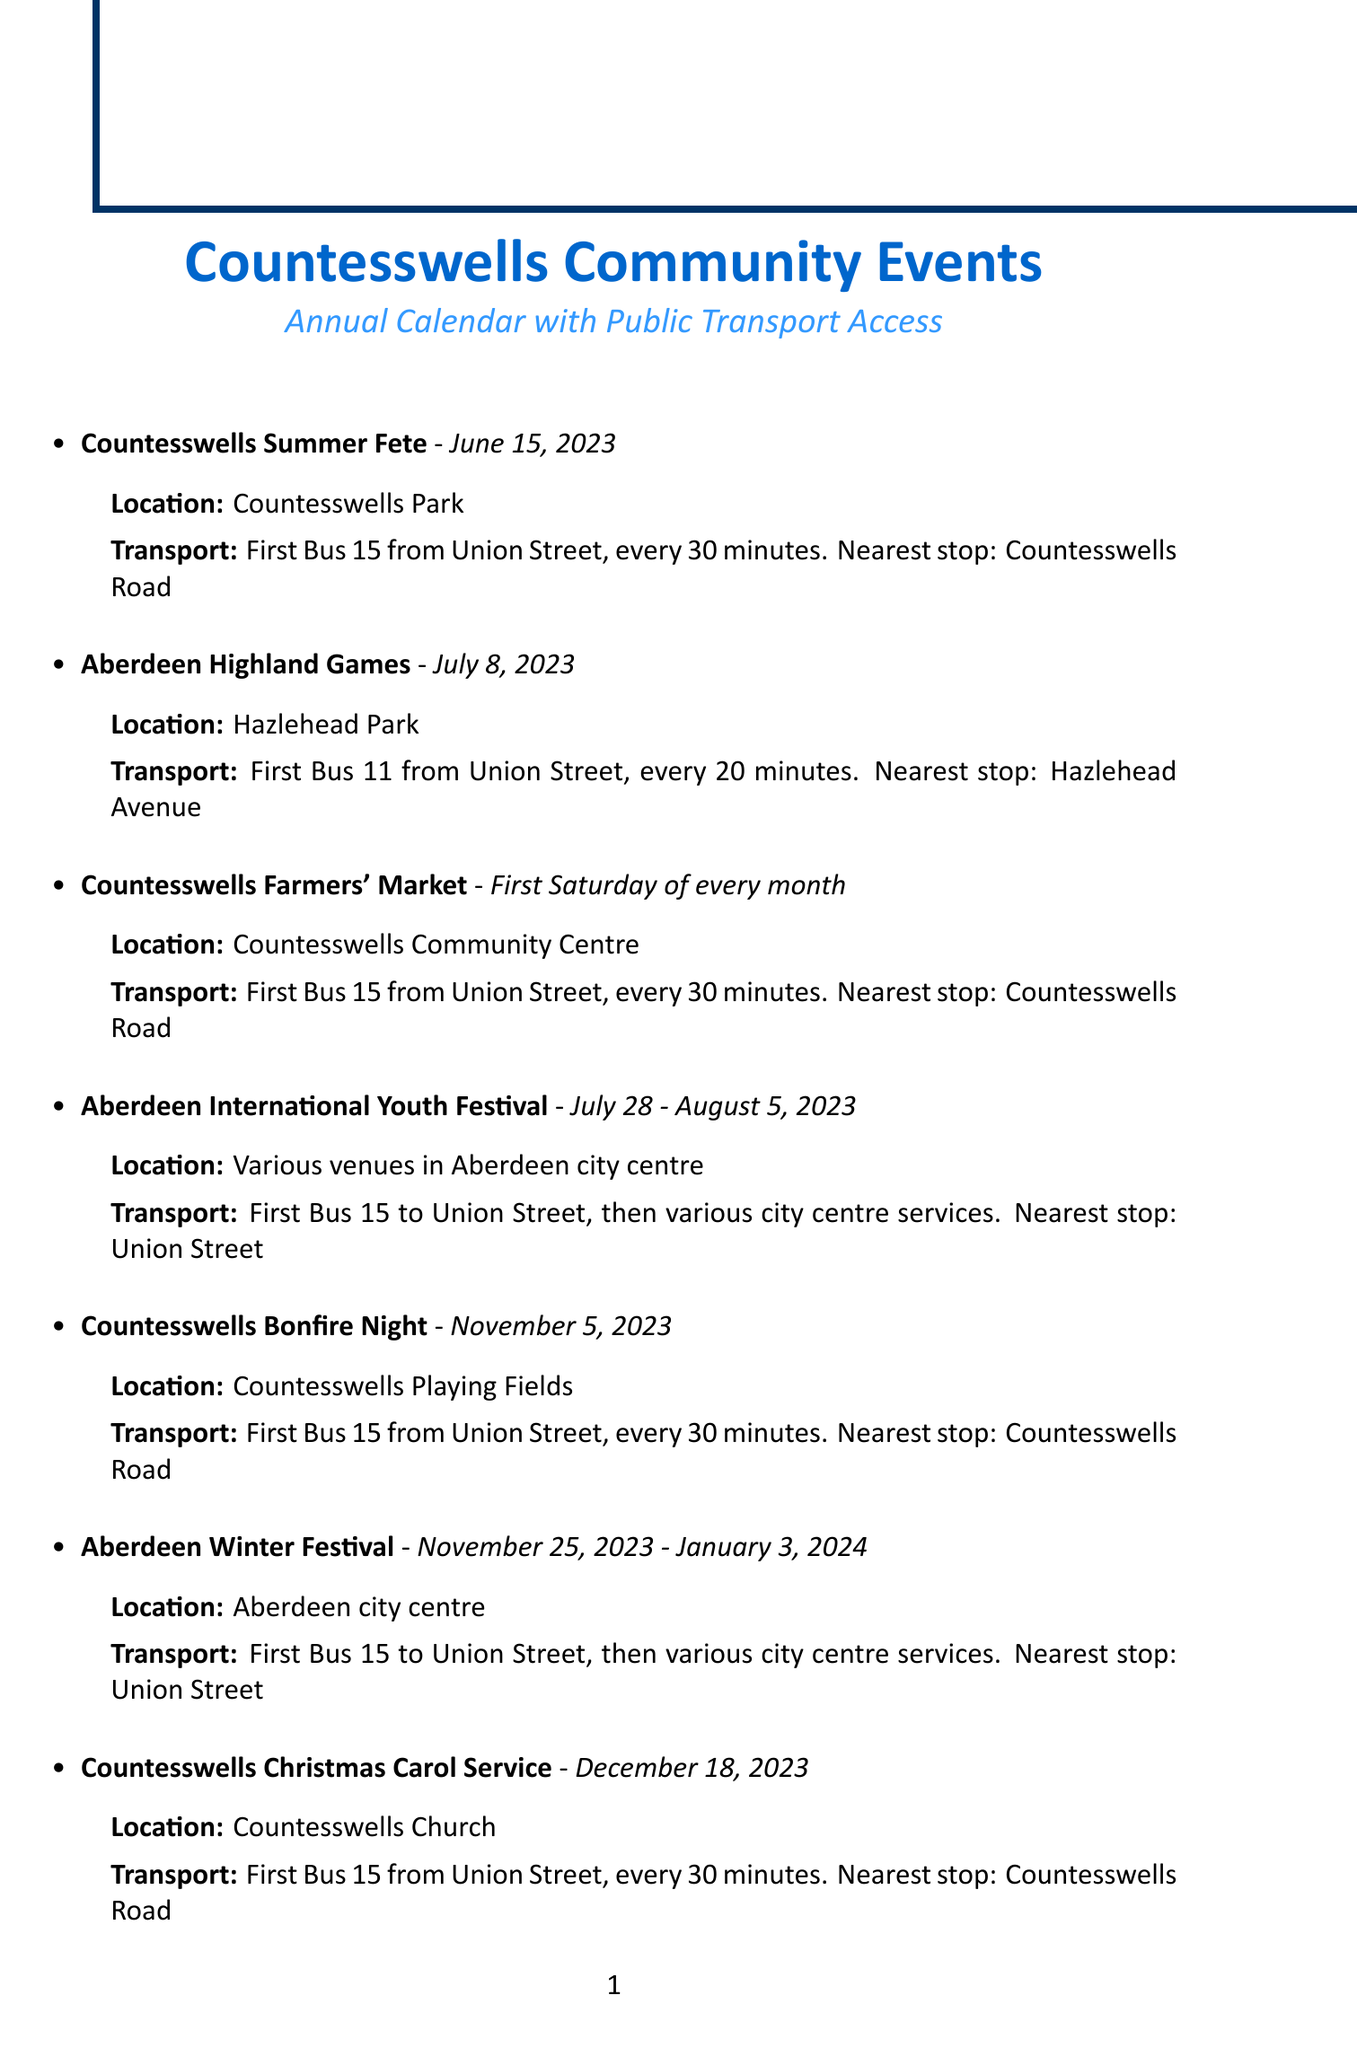What is the date of the Countesswells Summer Fete? The date for the Countesswells Summer Fete is explicitly mentioned in the document.
Answer: June 15, 2023 Where is the Aberdeen Highland Games being held? The document specifies the location of the Aberdeen Highland Games.
Answer: Hazlehead Park How often does the Countesswells Farmers' Market occur? The frequency of the Countesswells Farmers' Market is detailed in the event description.
Answer: First Saturday of every month What transport service goes to Countesswells Bonfire Night? The transport information indicates which bus service is available for the event.
Answer: First Bus 15 from Union Street, every 30 minutes What is the last date for the Aberdeen Winter Festival? The end date for the Aberdeen Winter Festival is included within the event dates in the document.
Answer: January 3, 2024 Which event involves community litter-picking? The document outlines various events, and this question checks knowledge of a specific community activity.
Answer: Countesswells Spring Clean How often does First Bus 15 run from Union Street to Countesswells? The document highlights the frequency of the bus service.
Answer: Every 30 minutes What is the venue for the Countesswells Christmas Carol Service? The venue for this specific event is mentioned directly in the document.
Answer: Countesswells Church Which event is scheduled for December 31, 2023? The date is listed along with the event in the document, highlighting specific timing.
Answer: Hogmanay Ceilidh 